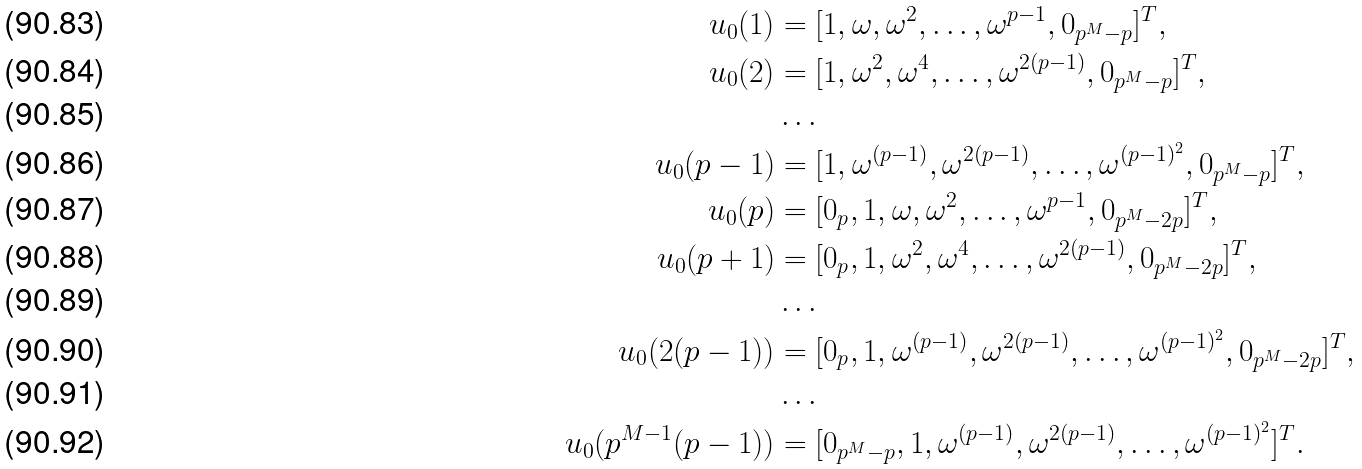Convert formula to latex. <formula><loc_0><loc_0><loc_500><loc_500>u _ { 0 } ( 1 ) & = [ 1 , \omega , \omega ^ { 2 } , \dots , \omega ^ { p - 1 } , 0 _ { p ^ { M } - p } ] ^ { T } , \\ u _ { 0 } ( 2 ) & = [ 1 , \omega ^ { 2 } , \omega ^ { 4 } , \dots , \omega ^ { 2 ( p - 1 ) } , 0 _ { p ^ { M } - p } ] ^ { T } , \\ & \dots \\ u _ { 0 } ( p - 1 ) & = [ 1 , \omega ^ { ( p - 1 ) } , \omega ^ { 2 ( p - 1 ) } , \dots , \omega ^ { ( p - 1 ) ^ { 2 } } , 0 _ { p ^ { M } - p } ] ^ { T } , \\ u _ { 0 } ( p ) & = [ 0 _ { p } , 1 , \omega , \omega ^ { 2 } , \dots , \omega ^ { p - 1 } , 0 _ { p ^ { M } - 2 p } ] ^ { T } , \\ u _ { 0 } ( p + 1 ) & = [ 0 _ { p } , 1 , \omega ^ { 2 } , \omega ^ { 4 } , \dots , \omega ^ { 2 ( p - 1 ) } , 0 _ { p ^ { M } - 2 p } ] ^ { T } , \\ & \dots \\ u _ { 0 } ( 2 ( p - 1 ) ) & = [ 0 _ { p } , 1 , \omega ^ { ( p - 1 ) } , \omega ^ { 2 ( p - 1 ) } , \dots , \omega ^ { ( p - 1 ) ^ { 2 } } , 0 _ { p ^ { M } - 2 p } ] ^ { T } , \\ & \dots \\ u _ { 0 } ( p ^ { M - 1 } ( p - 1 ) ) & = [ 0 _ { p ^ { M } - p } , 1 , \omega ^ { ( p - 1 ) } , \omega ^ { 2 ( p - 1 ) } , \dots , \omega ^ { ( p - 1 ) ^ { 2 } } ] ^ { T } .</formula> 